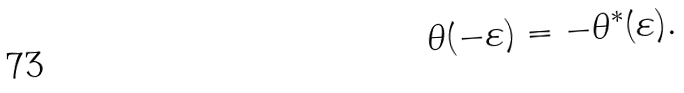<formula> <loc_0><loc_0><loc_500><loc_500>\theta ( - \varepsilon ) = - \theta ^ { \ast } ( \varepsilon ) .</formula> 